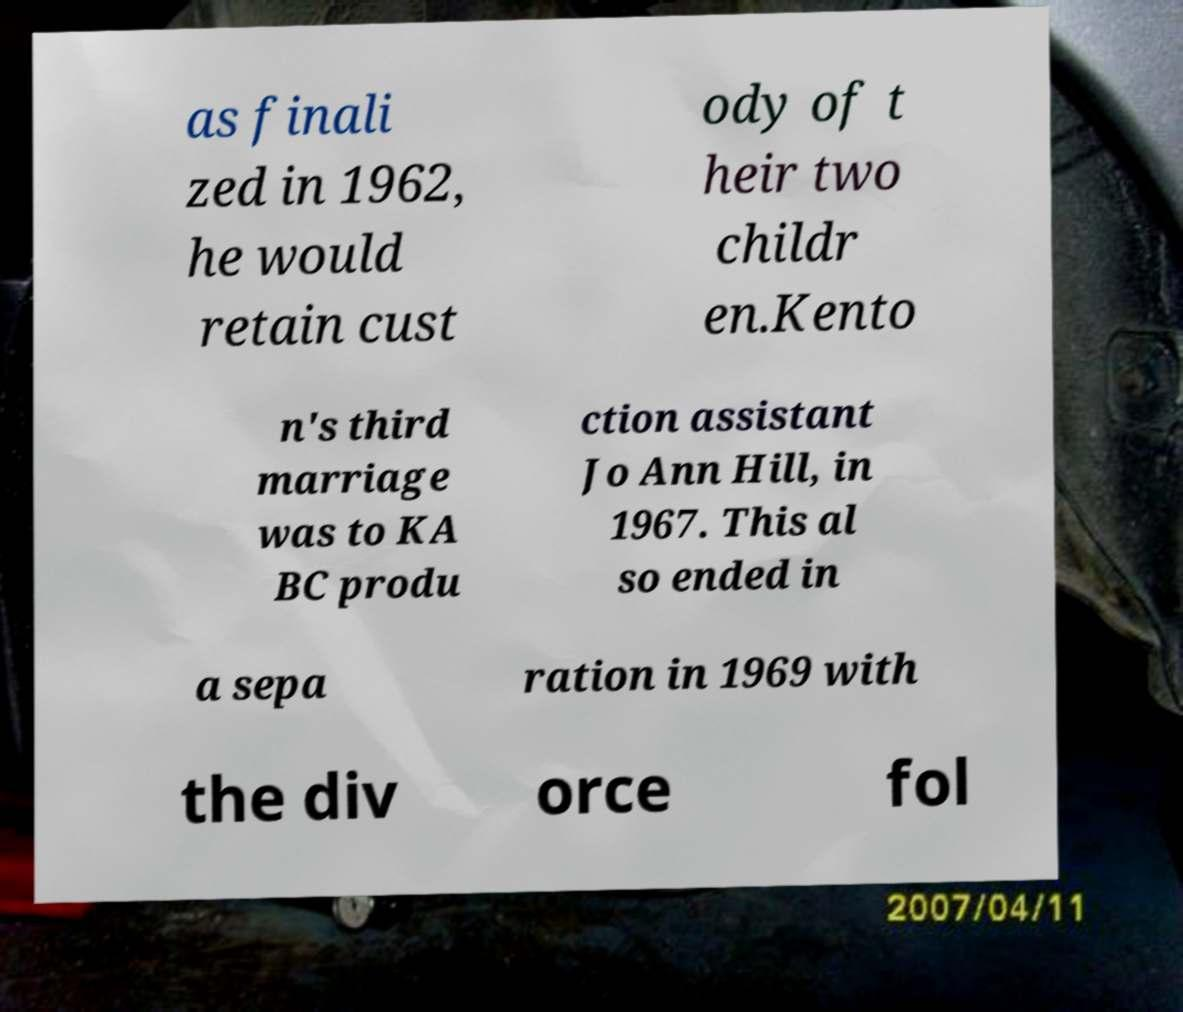Please identify and transcribe the text found in this image. as finali zed in 1962, he would retain cust ody of t heir two childr en.Kento n's third marriage was to KA BC produ ction assistant Jo Ann Hill, in 1967. This al so ended in a sepa ration in 1969 with the div orce fol 